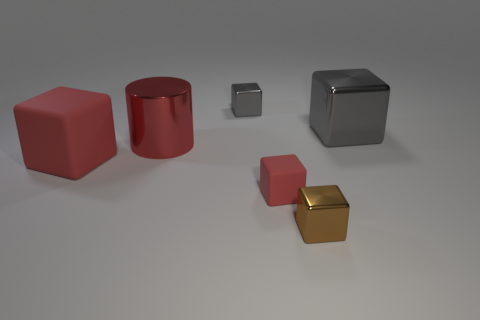What is the size of the cube that is the same color as the big rubber thing?
Offer a very short reply. Small. The gray object on the left side of the shiny object in front of the big matte object is what shape?
Offer a terse response. Cube. The big block that is in front of the big cylinder is what color?
Your response must be concise. Red. There is a red thing that is made of the same material as the tiny brown block; what size is it?
Keep it short and to the point. Large. The other rubber object that is the same shape as the tiny red matte thing is what size?
Your answer should be very brief. Large. Are any cyan metal blocks visible?
Your answer should be compact. No. How many objects are either gray metal objects that are to the left of the brown thing or brown objects?
Provide a short and direct response. 2. What material is the gray thing that is the same size as the brown shiny thing?
Your answer should be compact. Metal. There is a metal cube right of the metallic cube in front of the small red cube; what is its color?
Ensure brevity in your answer.  Gray. What number of tiny metal things are in front of the small brown block?
Make the answer very short. 0. 